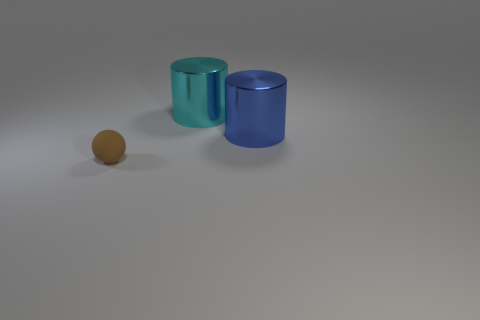Subtract all blue cylinders. How many cylinders are left? 1 Add 1 cylinders. How many objects exist? 4 Subtract all balls. How many objects are left? 2 Subtract 2 cylinders. How many cylinders are left? 0 Subtract all metallic objects. Subtract all small brown rubber objects. How many objects are left? 0 Add 1 large blue things. How many large blue things are left? 2 Add 1 large blue cylinders. How many large blue cylinders exist? 2 Subtract 0 green cubes. How many objects are left? 3 Subtract all cyan spheres. Subtract all purple cylinders. How many spheres are left? 1 Subtract all blue spheres. How many cyan cylinders are left? 1 